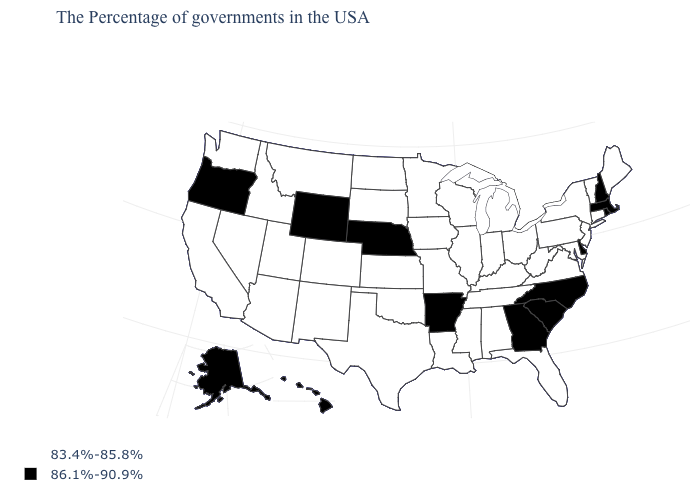Among the states that border Vermont , which have the lowest value?
Keep it brief. New York. What is the value of Kansas?
Be succinct. 83.4%-85.8%. What is the value of Michigan?
Concise answer only. 83.4%-85.8%. How many symbols are there in the legend?
Quick response, please. 2. What is the lowest value in the USA?
Be succinct. 83.4%-85.8%. Name the states that have a value in the range 83.4%-85.8%?
Concise answer only. Maine, Vermont, Connecticut, New York, New Jersey, Maryland, Pennsylvania, Virginia, West Virginia, Ohio, Florida, Michigan, Kentucky, Indiana, Alabama, Tennessee, Wisconsin, Illinois, Mississippi, Louisiana, Missouri, Minnesota, Iowa, Kansas, Oklahoma, Texas, South Dakota, North Dakota, Colorado, New Mexico, Utah, Montana, Arizona, Idaho, Nevada, California, Washington. How many symbols are there in the legend?
Give a very brief answer. 2. What is the lowest value in the MidWest?
Keep it brief. 83.4%-85.8%. What is the lowest value in the MidWest?
Write a very short answer. 83.4%-85.8%. Which states have the lowest value in the USA?
Give a very brief answer. Maine, Vermont, Connecticut, New York, New Jersey, Maryland, Pennsylvania, Virginia, West Virginia, Ohio, Florida, Michigan, Kentucky, Indiana, Alabama, Tennessee, Wisconsin, Illinois, Mississippi, Louisiana, Missouri, Minnesota, Iowa, Kansas, Oklahoma, Texas, South Dakota, North Dakota, Colorado, New Mexico, Utah, Montana, Arizona, Idaho, Nevada, California, Washington. What is the value of Indiana?
Quick response, please. 83.4%-85.8%. Does the first symbol in the legend represent the smallest category?
Short answer required. Yes. Name the states that have a value in the range 83.4%-85.8%?
Short answer required. Maine, Vermont, Connecticut, New York, New Jersey, Maryland, Pennsylvania, Virginia, West Virginia, Ohio, Florida, Michigan, Kentucky, Indiana, Alabama, Tennessee, Wisconsin, Illinois, Mississippi, Louisiana, Missouri, Minnesota, Iowa, Kansas, Oklahoma, Texas, South Dakota, North Dakota, Colorado, New Mexico, Utah, Montana, Arizona, Idaho, Nevada, California, Washington. Does the map have missing data?
Answer briefly. No. Does Missouri have the lowest value in the MidWest?
Quick response, please. Yes. 